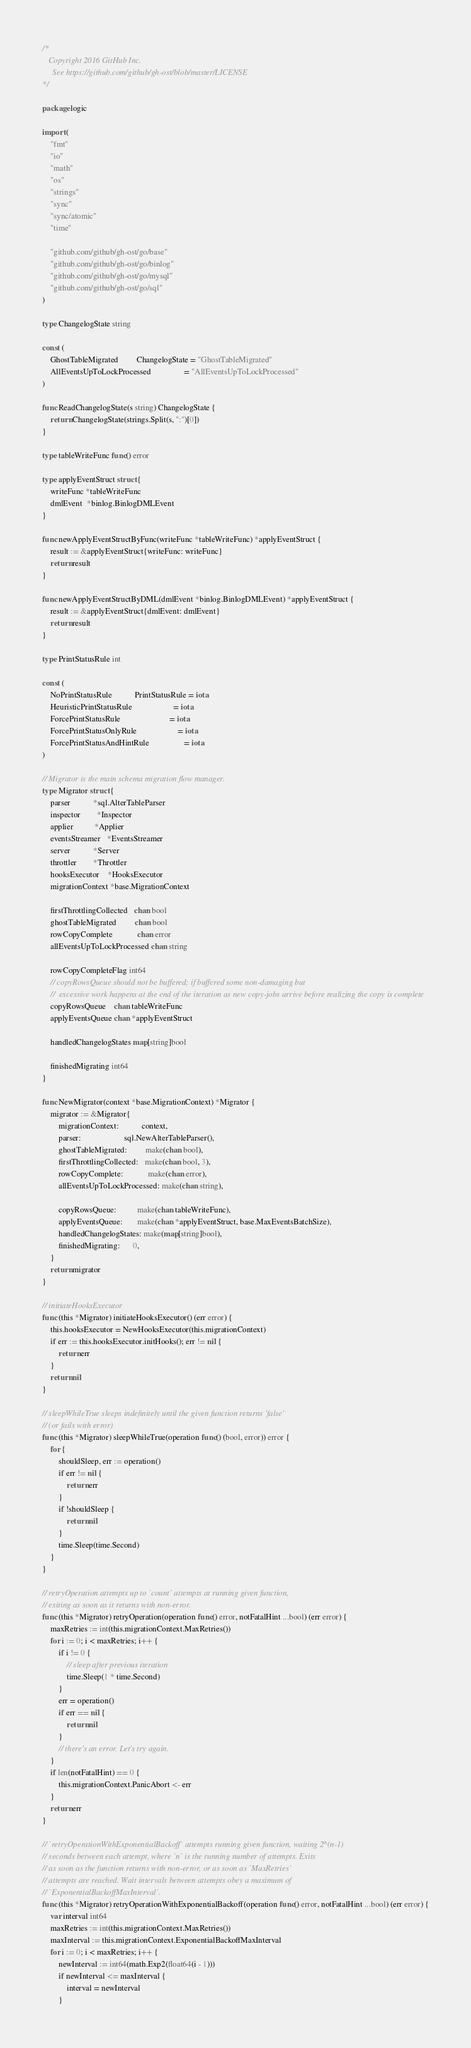Convert code to text. <code><loc_0><loc_0><loc_500><loc_500><_Go_>/*
   Copyright 2016 GitHub Inc.
	 See https://github.com/github/gh-ost/blob/master/LICENSE
*/

package logic

import (
	"fmt"
	"io"
	"math"
	"os"
	"strings"
	"sync"
	"sync/atomic"
	"time"

	"github.com/github/gh-ost/go/base"
	"github.com/github/gh-ost/go/binlog"
	"github.com/github/gh-ost/go/mysql"
	"github.com/github/gh-ost/go/sql"
)

type ChangelogState string

const (
	GhostTableMigrated         ChangelogState = "GhostTableMigrated"
	AllEventsUpToLockProcessed                = "AllEventsUpToLockProcessed"
)

func ReadChangelogState(s string) ChangelogState {
	return ChangelogState(strings.Split(s, ":")[0])
}

type tableWriteFunc func() error

type applyEventStruct struct {
	writeFunc *tableWriteFunc
	dmlEvent  *binlog.BinlogDMLEvent
}

func newApplyEventStructByFunc(writeFunc *tableWriteFunc) *applyEventStruct {
	result := &applyEventStruct{writeFunc: writeFunc}
	return result
}

func newApplyEventStructByDML(dmlEvent *binlog.BinlogDMLEvent) *applyEventStruct {
	result := &applyEventStruct{dmlEvent: dmlEvent}
	return result
}

type PrintStatusRule int

const (
	NoPrintStatusRule           PrintStatusRule = iota
	HeuristicPrintStatusRule                    = iota
	ForcePrintStatusRule                        = iota
	ForcePrintStatusOnlyRule                    = iota
	ForcePrintStatusAndHintRule                 = iota
)

// Migrator is the main schema migration flow manager.
type Migrator struct {
	parser           *sql.AlterTableParser
	inspector        *Inspector
	applier          *Applier
	eventsStreamer   *EventsStreamer
	server           *Server
	throttler        *Throttler
	hooksExecutor    *HooksExecutor
	migrationContext *base.MigrationContext

	firstThrottlingCollected   chan bool
	ghostTableMigrated         chan bool
	rowCopyComplete            chan error
	allEventsUpToLockProcessed chan string

	rowCopyCompleteFlag int64
	// copyRowsQueue should not be buffered; if buffered some non-damaging but
	//  excessive work happens at the end of the iteration as new copy-jobs arrive before realizing the copy is complete
	copyRowsQueue    chan tableWriteFunc
	applyEventsQueue chan *applyEventStruct

	handledChangelogStates map[string]bool

	finishedMigrating int64
}

func NewMigrator(context *base.MigrationContext) *Migrator {
	migrator := &Migrator{
		migrationContext:           context,
		parser:                     sql.NewAlterTableParser(),
		ghostTableMigrated:         make(chan bool),
		firstThrottlingCollected:   make(chan bool, 3),
		rowCopyComplete:            make(chan error),
		allEventsUpToLockProcessed: make(chan string),

		copyRowsQueue:          make(chan tableWriteFunc),
		applyEventsQueue:       make(chan *applyEventStruct, base.MaxEventsBatchSize),
		handledChangelogStates: make(map[string]bool),
		finishedMigrating:      0,
	}
	return migrator
}

// initiateHooksExecutor
func (this *Migrator) initiateHooksExecutor() (err error) {
	this.hooksExecutor = NewHooksExecutor(this.migrationContext)
	if err := this.hooksExecutor.initHooks(); err != nil {
		return err
	}
	return nil
}

// sleepWhileTrue sleeps indefinitely until the given function returns 'false'
// (or fails with error)
func (this *Migrator) sleepWhileTrue(operation func() (bool, error)) error {
	for {
		shouldSleep, err := operation()
		if err != nil {
			return err
		}
		if !shouldSleep {
			return nil
		}
		time.Sleep(time.Second)
	}
}

// retryOperation attempts up to `count` attempts at running given function,
// exiting as soon as it returns with non-error.
func (this *Migrator) retryOperation(operation func() error, notFatalHint ...bool) (err error) {
	maxRetries := int(this.migrationContext.MaxRetries())
	for i := 0; i < maxRetries; i++ {
		if i != 0 {
			// sleep after previous iteration
			time.Sleep(1 * time.Second)
		}
		err = operation()
		if err == nil {
			return nil
		}
		// there's an error. Let's try again.
	}
	if len(notFatalHint) == 0 {
		this.migrationContext.PanicAbort <- err
	}
	return err
}

// `retryOperationWithExponentialBackoff` attempts running given function, waiting 2^(n-1)
// seconds between each attempt, where `n` is the running number of attempts. Exits
// as soon as the function returns with non-error, or as soon as `MaxRetries`
// attempts are reached. Wait intervals between attempts obey a maximum of
// `ExponentialBackoffMaxInterval`.
func (this *Migrator) retryOperationWithExponentialBackoff(operation func() error, notFatalHint ...bool) (err error) {
	var interval int64
	maxRetries := int(this.migrationContext.MaxRetries())
	maxInterval := this.migrationContext.ExponentialBackoffMaxInterval
	for i := 0; i < maxRetries; i++ {
		newInterval := int64(math.Exp2(float64(i - 1)))
		if newInterval <= maxInterval {
			interval = newInterval
		}</code> 